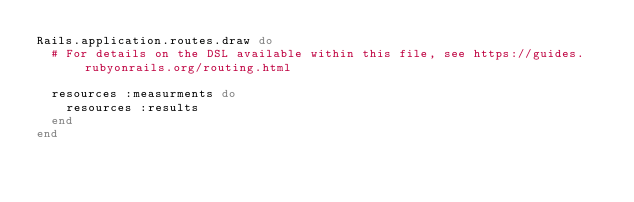Convert code to text. <code><loc_0><loc_0><loc_500><loc_500><_Ruby_>Rails.application.routes.draw do
  # For details on the DSL available within this file, see https://guides.rubyonrails.org/routing.html

  resources :measurments do
    resources :results
  end
end
</code> 